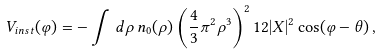<formula> <loc_0><loc_0><loc_500><loc_500>V _ { i n s t } ( \varphi ) = - \int \, d \rho \, n _ { 0 } ( \rho ) \left ( { \frac { 4 } { 3 } } \pi ^ { 2 } \rho ^ { 3 } \right ) ^ { 2 } 1 2 | X | ^ { 2 } \cos ( \varphi - \theta ) \, ,</formula> 